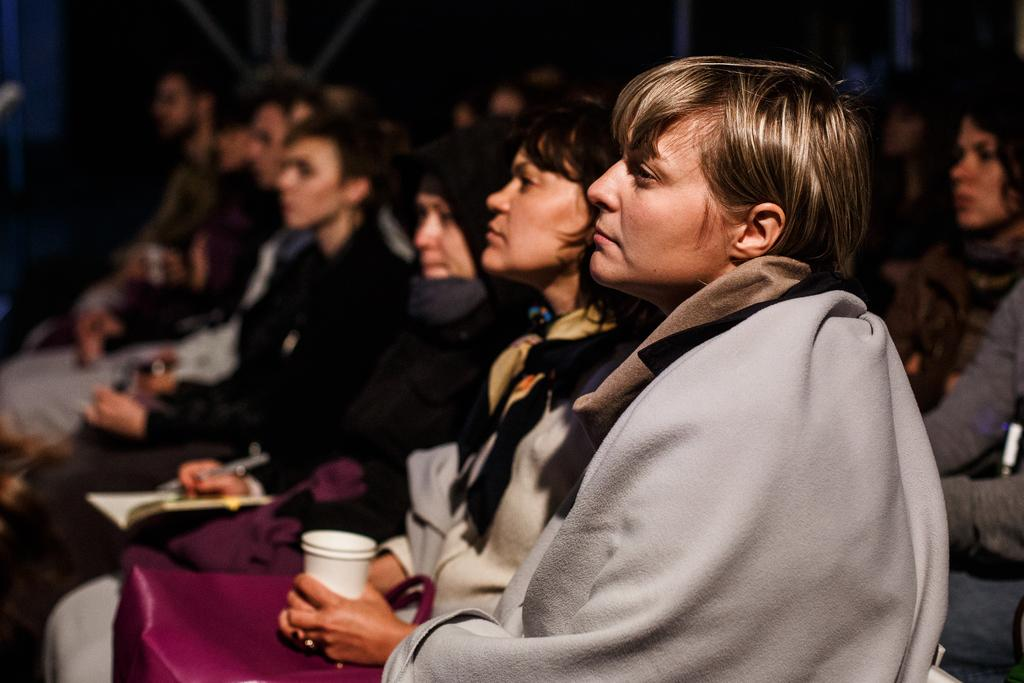What are the people in the image doing? The people in the image are sitting on chairs. What can be seen in the image besides the people sitting on chairs? There are metal rods visible in the image. What type of basin is being used to make a decision in the image? There is no basin or decision-making process depicted in the image. How many buns are visible on the chairs in the image? There are no buns present in the image. 